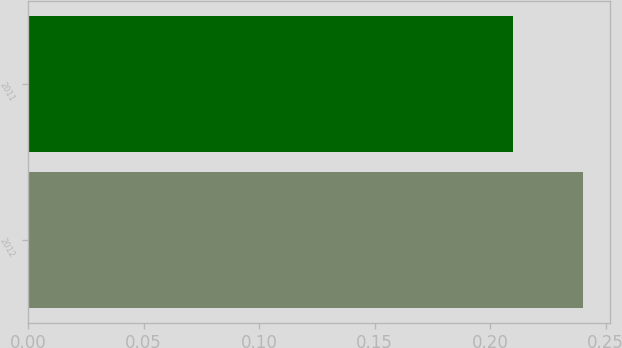<chart> <loc_0><loc_0><loc_500><loc_500><bar_chart><fcel>2012<fcel>2011<nl><fcel>0.24<fcel>0.21<nl></chart> 